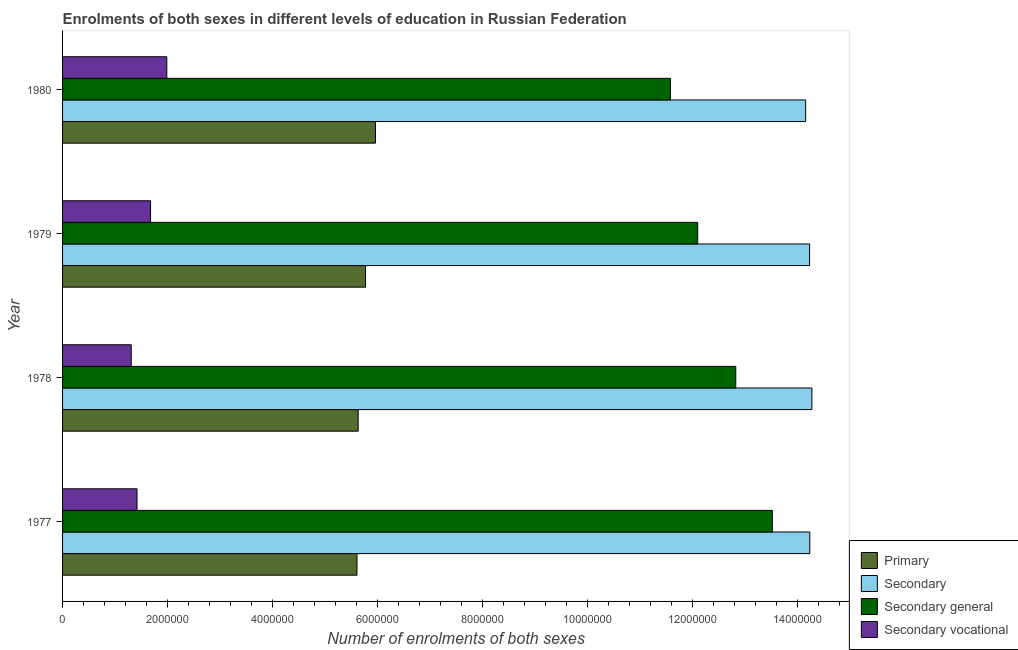Are the number of bars per tick equal to the number of legend labels?
Your answer should be compact. Yes. How many bars are there on the 4th tick from the bottom?
Your answer should be very brief. 4. What is the label of the 1st group of bars from the top?
Provide a succinct answer. 1980. What is the number of enrolments in secondary education in 1978?
Your response must be concise. 1.43e+07. Across all years, what is the maximum number of enrolments in secondary education?
Give a very brief answer. 1.43e+07. Across all years, what is the minimum number of enrolments in secondary education?
Ensure brevity in your answer.  1.42e+07. In which year was the number of enrolments in secondary vocational education maximum?
Give a very brief answer. 1980. In which year was the number of enrolments in secondary vocational education minimum?
Ensure brevity in your answer.  1978. What is the total number of enrolments in primary education in the graph?
Ensure brevity in your answer.  2.30e+07. What is the difference between the number of enrolments in secondary education in 1978 and that in 1979?
Give a very brief answer. 4.33e+04. What is the difference between the number of enrolments in primary education in 1980 and the number of enrolments in secondary vocational education in 1978?
Give a very brief answer. 4.65e+06. What is the average number of enrolments in secondary education per year?
Ensure brevity in your answer.  1.42e+07. In the year 1978, what is the difference between the number of enrolments in secondary general education and number of enrolments in secondary vocational education?
Offer a very short reply. 1.15e+07. In how many years, is the number of enrolments in primary education greater than 8800000 ?
Offer a very short reply. 0. What is the ratio of the number of enrolments in primary education in 1979 to that in 1980?
Your answer should be very brief. 0.97. Is the difference between the number of enrolments in secondary vocational education in 1979 and 1980 greater than the difference between the number of enrolments in primary education in 1979 and 1980?
Make the answer very short. No. What is the difference between the highest and the second highest number of enrolments in secondary education?
Your answer should be very brief. 4.00e+04. What is the difference between the highest and the lowest number of enrolments in secondary education?
Offer a terse response. 1.19e+05. Is the sum of the number of enrolments in secondary education in 1979 and 1980 greater than the maximum number of enrolments in primary education across all years?
Ensure brevity in your answer.  Yes. Is it the case that in every year, the sum of the number of enrolments in secondary general education and number of enrolments in primary education is greater than the sum of number of enrolments in secondary vocational education and number of enrolments in secondary education?
Give a very brief answer. Yes. What does the 3rd bar from the top in 1979 represents?
Your response must be concise. Secondary. What does the 1st bar from the bottom in 1980 represents?
Give a very brief answer. Primary. Is it the case that in every year, the sum of the number of enrolments in primary education and number of enrolments in secondary education is greater than the number of enrolments in secondary general education?
Make the answer very short. Yes. Are all the bars in the graph horizontal?
Provide a succinct answer. Yes. How many years are there in the graph?
Offer a very short reply. 4. Are the values on the major ticks of X-axis written in scientific E-notation?
Your answer should be very brief. No. Does the graph contain any zero values?
Give a very brief answer. No. What is the title of the graph?
Make the answer very short. Enrolments of both sexes in different levels of education in Russian Federation. Does "Structural Policies" appear as one of the legend labels in the graph?
Your response must be concise. No. What is the label or title of the X-axis?
Make the answer very short. Number of enrolments of both sexes. What is the Number of enrolments of both sexes in Primary in 1977?
Your response must be concise. 5.61e+06. What is the Number of enrolments of both sexes in Secondary in 1977?
Offer a very short reply. 1.42e+07. What is the Number of enrolments of both sexes of Secondary general in 1977?
Make the answer very short. 1.35e+07. What is the Number of enrolments of both sexes in Secondary vocational in 1977?
Your answer should be very brief. 1.42e+06. What is the Number of enrolments of both sexes in Primary in 1978?
Your response must be concise. 5.63e+06. What is the Number of enrolments of both sexes of Secondary in 1978?
Your answer should be very brief. 1.43e+07. What is the Number of enrolments of both sexes in Secondary general in 1978?
Give a very brief answer. 1.28e+07. What is the Number of enrolments of both sexes in Secondary vocational in 1978?
Your answer should be compact. 1.31e+06. What is the Number of enrolments of both sexes in Primary in 1979?
Your response must be concise. 5.77e+06. What is the Number of enrolments of both sexes in Secondary in 1979?
Provide a short and direct response. 1.42e+07. What is the Number of enrolments of both sexes in Secondary general in 1979?
Ensure brevity in your answer.  1.21e+07. What is the Number of enrolments of both sexes of Secondary vocational in 1979?
Your answer should be very brief. 1.68e+06. What is the Number of enrolments of both sexes of Primary in 1980?
Offer a terse response. 5.96e+06. What is the Number of enrolments of both sexes in Secondary in 1980?
Give a very brief answer. 1.42e+07. What is the Number of enrolments of both sexes in Secondary general in 1980?
Make the answer very short. 1.16e+07. What is the Number of enrolments of both sexes of Secondary vocational in 1980?
Offer a terse response. 1.99e+06. Across all years, what is the maximum Number of enrolments of both sexes in Primary?
Provide a short and direct response. 5.96e+06. Across all years, what is the maximum Number of enrolments of both sexes of Secondary?
Your answer should be compact. 1.43e+07. Across all years, what is the maximum Number of enrolments of both sexes of Secondary general?
Your answer should be compact. 1.35e+07. Across all years, what is the maximum Number of enrolments of both sexes in Secondary vocational?
Keep it short and to the point. 1.99e+06. Across all years, what is the minimum Number of enrolments of both sexes of Primary?
Offer a terse response. 5.61e+06. Across all years, what is the minimum Number of enrolments of both sexes of Secondary?
Offer a very short reply. 1.42e+07. Across all years, what is the minimum Number of enrolments of both sexes in Secondary general?
Provide a succinct answer. 1.16e+07. Across all years, what is the minimum Number of enrolments of both sexes in Secondary vocational?
Offer a terse response. 1.31e+06. What is the total Number of enrolments of both sexes in Primary in the graph?
Ensure brevity in your answer.  2.30e+07. What is the total Number of enrolments of both sexes in Secondary in the graph?
Provide a succinct answer. 5.69e+07. What is the total Number of enrolments of both sexes of Secondary general in the graph?
Provide a short and direct response. 5.00e+07. What is the total Number of enrolments of both sexes of Secondary vocational in the graph?
Give a very brief answer. 6.39e+06. What is the difference between the Number of enrolments of both sexes in Primary in 1977 and that in 1978?
Your answer should be very brief. -2.30e+04. What is the difference between the Number of enrolments of both sexes of Secondary general in 1977 and that in 1978?
Your answer should be very brief. 6.97e+05. What is the difference between the Number of enrolments of both sexes of Secondary vocational in 1977 and that in 1978?
Offer a very short reply. 1.10e+05. What is the difference between the Number of enrolments of both sexes of Primary in 1977 and that in 1979?
Provide a short and direct response. -1.63e+05. What is the difference between the Number of enrolments of both sexes in Secondary in 1977 and that in 1979?
Offer a terse response. 3320. What is the difference between the Number of enrolments of both sexes of Secondary general in 1977 and that in 1979?
Your answer should be very brief. 1.42e+06. What is the difference between the Number of enrolments of both sexes of Secondary vocational in 1977 and that in 1979?
Your answer should be very brief. -2.58e+05. What is the difference between the Number of enrolments of both sexes in Primary in 1977 and that in 1980?
Offer a very short reply. -3.53e+05. What is the difference between the Number of enrolments of both sexes of Secondary in 1977 and that in 1980?
Make the answer very short. 7.85e+04. What is the difference between the Number of enrolments of both sexes of Secondary general in 1977 and that in 1980?
Keep it short and to the point. 1.94e+06. What is the difference between the Number of enrolments of both sexes of Secondary vocational in 1977 and that in 1980?
Your response must be concise. -5.67e+05. What is the difference between the Number of enrolments of both sexes of Secondary in 1978 and that in 1979?
Give a very brief answer. 4.33e+04. What is the difference between the Number of enrolments of both sexes of Secondary general in 1978 and that in 1979?
Provide a succinct answer. 7.25e+05. What is the difference between the Number of enrolments of both sexes in Secondary vocational in 1978 and that in 1979?
Provide a succinct answer. -3.68e+05. What is the difference between the Number of enrolments of both sexes of Primary in 1978 and that in 1980?
Offer a terse response. -3.30e+05. What is the difference between the Number of enrolments of both sexes in Secondary in 1978 and that in 1980?
Keep it short and to the point. 1.19e+05. What is the difference between the Number of enrolments of both sexes of Secondary general in 1978 and that in 1980?
Your answer should be compact. 1.24e+06. What is the difference between the Number of enrolments of both sexes of Secondary vocational in 1978 and that in 1980?
Make the answer very short. -6.77e+05. What is the difference between the Number of enrolments of both sexes of Primary in 1979 and that in 1980?
Your response must be concise. -1.90e+05. What is the difference between the Number of enrolments of both sexes of Secondary in 1979 and that in 1980?
Your answer should be compact. 7.52e+04. What is the difference between the Number of enrolments of both sexes of Secondary general in 1979 and that in 1980?
Offer a very short reply. 5.20e+05. What is the difference between the Number of enrolments of both sexes of Secondary vocational in 1979 and that in 1980?
Your response must be concise. -3.09e+05. What is the difference between the Number of enrolments of both sexes of Primary in 1977 and the Number of enrolments of both sexes of Secondary in 1978?
Your answer should be compact. -8.66e+06. What is the difference between the Number of enrolments of both sexes of Primary in 1977 and the Number of enrolments of both sexes of Secondary general in 1978?
Offer a very short reply. -7.22e+06. What is the difference between the Number of enrolments of both sexes in Primary in 1977 and the Number of enrolments of both sexes in Secondary vocational in 1978?
Offer a terse response. 4.30e+06. What is the difference between the Number of enrolments of both sexes in Secondary in 1977 and the Number of enrolments of both sexes in Secondary general in 1978?
Provide a succinct answer. 1.41e+06. What is the difference between the Number of enrolments of both sexes of Secondary in 1977 and the Number of enrolments of both sexes of Secondary vocational in 1978?
Provide a succinct answer. 1.29e+07. What is the difference between the Number of enrolments of both sexes in Secondary general in 1977 and the Number of enrolments of both sexes in Secondary vocational in 1978?
Ensure brevity in your answer.  1.22e+07. What is the difference between the Number of enrolments of both sexes in Primary in 1977 and the Number of enrolments of both sexes in Secondary in 1979?
Your response must be concise. -8.62e+06. What is the difference between the Number of enrolments of both sexes in Primary in 1977 and the Number of enrolments of both sexes in Secondary general in 1979?
Your answer should be very brief. -6.49e+06. What is the difference between the Number of enrolments of both sexes of Primary in 1977 and the Number of enrolments of both sexes of Secondary vocational in 1979?
Your response must be concise. 3.93e+06. What is the difference between the Number of enrolments of both sexes in Secondary in 1977 and the Number of enrolments of both sexes in Secondary general in 1979?
Your answer should be very brief. 2.14e+06. What is the difference between the Number of enrolments of both sexes of Secondary in 1977 and the Number of enrolments of both sexes of Secondary vocational in 1979?
Offer a very short reply. 1.26e+07. What is the difference between the Number of enrolments of both sexes of Secondary general in 1977 and the Number of enrolments of both sexes of Secondary vocational in 1979?
Offer a very short reply. 1.18e+07. What is the difference between the Number of enrolments of both sexes of Primary in 1977 and the Number of enrolments of both sexes of Secondary in 1980?
Keep it short and to the point. -8.55e+06. What is the difference between the Number of enrolments of both sexes in Primary in 1977 and the Number of enrolments of both sexes in Secondary general in 1980?
Make the answer very short. -5.97e+06. What is the difference between the Number of enrolments of both sexes in Primary in 1977 and the Number of enrolments of both sexes in Secondary vocational in 1980?
Ensure brevity in your answer.  3.62e+06. What is the difference between the Number of enrolments of both sexes of Secondary in 1977 and the Number of enrolments of both sexes of Secondary general in 1980?
Provide a succinct answer. 2.66e+06. What is the difference between the Number of enrolments of both sexes in Secondary in 1977 and the Number of enrolments of both sexes in Secondary vocational in 1980?
Provide a short and direct response. 1.22e+07. What is the difference between the Number of enrolments of both sexes of Secondary general in 1977 and the Number of enrolments of both sexes of Secondary vocational in 1980?
Your answer should be compact. 1.15e+07. What is the difference between the Number of enrolments of both sexes of Primary in 1978 and the Number of enrolments of both sexes of Secondary in 1979?
Ensure brevity in your answer.  -8.60e+06. What is the difference between the Number of enrolments of both sexes in Primary in 1978 and the Number of enrolments of both sexes in Secondary general in 1979?
Your answer should be very brief. -6.47e+06. What is the difference between the Number of enrolments of both sexes of Primary in 1978 and the Number of enrolments of both sexes of Secondary vocational in 1979?
Your answer should be very brief. 3.96e+06. What is the difference between the Number of enrolments of both sexes in Secondary in 1978 and the Number of enrolments of both sexes in Secondary general in 1979?
Your response must be concise. 2.18e+06. What is the difference between the Number of enrolments of both sexes of Secondary in 1978 and the Number of enrolments of both sexes of Secondary vocational in 1979?
Your answer should be compact. 1.26e+07. What is the difference between the Number of enrolments of both sexes in Secondary general in 1978 and the Number of enrolments of both sexes in Secondary vocational in 1979?
Your response must be concise. 1.11e+07. What is the difference between the Number of enrolments of both sexes of Primary in 1978 and the Number of enrolments of both sexes of Secondary in 1980?
Give a very brief answer. -8.52e+06. What is the difference between the Number of enrolments of both sexes of Primary in 1978 and the Number of enrolments of both sexes of Secondary general in 1980?
Offer a very short reply. -5.95e+06. What is the difference between the Number of enrolments of both sexes in Primary in 1978 and the Number of enrolments of both sexes in Secondary vocational in 1980?
Provide a succinct answer. 3.65e+06. What is the difference between the Number of enrolments of both sexes in Secondary in 1978 and the Number of enrolments of both sexes in Secondary general in 1980?
Provide a succinct answer. 2.70e+06. What is the difference between the Number of enrolments of both sexes in Secondary in 1978 and the Number of enrolments of both sexes in Secondary vocational in 1980?
Offer a terse response. 1.23e+07. What is the difference between the Number of enrolments of both sexes of Secondary general in 1978 and the Number of enrolments of both sexes of Secondary vocational in 1980?
Make the answer very short. 1.08e+07. What is the difference between the Number of enrolments of both sexes of Primary in 1979 and the Number of enrolments of both sexes of Secondary in 1980?
Your answer should be compact. -8.38e+06. What is the difference between the Number of enrolments of both sexes in Primary in 1979 and the Number of enrolments of both sexes in Secondary general in 1980?
Provide a succinct answer. -5.81e+06. What is the difference between the Number of enrolments of both sexes in Primary in 1979 and the Number of enrolments of both sexes in Secondary vocational in 1980?
Give a very brief answer. 3.79e+06. What is the difference between the Number of enrolments of both sexes of Secondary in 1979 and the Number of enrolments of both sexes of Secondary general in 1980?
Make the answer very short. 2.65e+06. What is the difference between the Number of enrolments of both sexes of Secondary in 1979 and the Number of enrolments of both sexes of Secondary vocational in 1980?
Ensure brevity in your answer.  1.22e+07. What is the difference between the Number of enrolments of both sexes in Secondary general in 1979 and the Number of enrolments of both sexes in Secondary vocational in 1980?
Your answer should be compact. 1.01e+07. What is the average Number of enrolments of both sexes in Primary per year?
Make the answer very short. 5.74e+06. What is the average Number of enrolments of both sexes of Secondary per year?
Your answer should be compact. 1.42e+07. What is the average Number of enrolments of both sexes in Secondary general per year?
Make the answer very short. 1.25e+07. What is the average Number of enrolments of both sexes in Secondary vocational per year?
Your response must be concise. 1.60e+06. In the year 1977, what is the difference between the Number of enrolments of both sexes in Primary and Number of enrolments of both sexes in Secondary?
Provide a succinct answer. -8.62e+06. In the year 1977, what is the difference between the Number of enrolments of both sexes in Primary and Number of enrolments of both sexes in Secondary general?
Keep it short and to the point. -7.91e+06. In the year 1977, what is the difference between the Number of enrolments of both sexes of Primary and Number of enrolments of both sexes of Secondary vocational?
Your response must be concise. 4.19e+06. In the year 1977, what is the difference between the Number of enrolments of both sexes of Secondary and Number of enrolments of both sexes of Secondary general?
Keep it short and to the point. 7.13e+05. In the year 1977, what is the difference between the Number of enrolments of both sexes of Secondary and Number of enrolments of both sexes of Secondary vocational?
Ensure brevity in your answer.  1.28e+07. In the year 1977, what is the difference between the Number of enrolments of both sexes in Secondary general and Number of enrolments of both sexes in Secondary vocational?
Your answer should be very brief. 1.21e+07. In the year 1978, what is the difference between the Number of enrolments of both sexes of Primary and Number of enrolments of both sexes of Secondary?
Ensure brevity in your answer.  -8.64e+06. In the year 1978, what is the difference between the Number of enrolments of both sexes of Primary and Number of enrolments of both sexes of Secondary general?
Your response must be concise. -7.19e+06. In the year 1978, what is the difference between the Number of enrolments of both sexes in Primary and Number of enrolments of both sexes in Secondary vocational?
Your answer should be compact. 4.32e+06. In the year 1978, what is the difference between the Number of enrolments of both sexes of Secondary and Number of enrolments of both sexes of Secondary general?
Offer a terse response. 1.45e+06. In the year 1978, what is the difference between the Number of enrolments of both sexes in Secondary and Number of enrolments of both sexes in Secondary vocational?
Ensure brevity in your answer.  1.30e+07. In the year 1978, what is the difference between the Number of enrolments of both sexes of Secondary general and Number of enrolments of both sexes of Secondary vocational?
Keep it short and to the point. 1.15e+07. In the year 1979, what is the difference between the Number of enrolments of both sexes in Primary and Number of enrolments of both sexes in Secondary?
Give a very brief answer. -8.46e+06. In the year 1979, what is the difference between the Number of enrolments of both sexes of Primary and Number of enrolments of both sexes of Secondary general?
Ensure brevity in your answer.  -6.33e+06. In the year 1979, what is the difference between the Number of enrolments of both sexes in Primary and Number of enrolments of both sexes in Secondary vocational?
Your response must be concise. 4.10e+06. In the year 1979, what is the difference between the Number of enrolments of both sexes of Secondary and Number of enrolments of both sexes of Secondary general?
Keep it short and to the point. 2.13e+06. In the year 1979, what is the difference between the Number of enrolments of both sexes in Secondary and Number of enrolments of both sexes in Secondary vocational?
Make the answer very short. 1.26e+07. In the year 1979, what is the difference between the Number of enrolments of both sexes in Secondary general and Number of enrolments of both sexes in Secondary vocational?
Make the answer very short. 1.04e+07. In the year 1980, what is the difference between the Number of enrolments of both sexes of Primary and Number of enrolments of both sexes of Secondary?
Your response must be concise. -8.19e+06. In the year 1980, what is the difference between the Number of enrolments of both sexes in Primary and Number of enrolments of both sexes in Secondary general?
Your response must be concise. -5.62e+06. In the year 1980, what is the difference between the Number of enrolments of both sexes in Primary and Number of enrolments of both sexes in Secondary vocational?
Give a very brief answer. 3.98e+06. In the year 1980, what is the difference between the Number of enrolments of both sexes in Secondary and Number of enrolments of both sexes in Secondary general?
Your answer should be compact. 2.58e+06. In the year 1980, what is the difference between the Number of enrolments of both sexes of Secondary and Number of enrolments of both sexes of Secondary vocational?
Your answer should be very brief. 1.22e+07. In the year 1980, what is the difference between the Number of enrolments of both sexes in Secondary general and Number of enrolments of both sexes in Secondary vocational?
Your answer should be very brief. 9.59e+06. What is the ratio of the Number of enrolments of both sexes in Secondary in 1977 to that in 1978?
Ensure brevity in your answer.  1. What is the ratio of the Number of enrolments of both sexes of Secondary general in 1977 to that in 1978?
Give a very brief answer. 1.05. What is the ratio of the Number of enrolments of both sexes in Secondary vocational in 1977 to that in 1978?
Offer a very short reply. 1.08. What is the ratio of the Number of enrolments of both sexes of Primary in 1977 to that in 1979?
Provide a short and direct response. 0.97. What is the ratio of the Number of enrolments of both sexes in Secondary in 1977 to that in 1979?
Offer a terse response. 1. What is the ratio of the Number of enrolments of both sexes of Secondary general in 1977 to that in 1979?
Give a very brief answer. 1.12. What is the ratio of the Number of enrolments of both sexes in Secondary vocational in 1977 to that in 1979?
Offer a very short reply. 0.85. What is the ratio of the Number of enrolments of both sexes of Primary in 1977 to that in 1980?
Offer a terse response. 0.94. What is the ratio of the Number of enrolments of both sexes in Secondary general in 1977 to that in 1980?
Your answer should be very brief. 1.17. What is the ratio of the Number of enrolments of both sexes in Primary in 1978 to that in 1979?
Your response must be concise. 0.98. What is the ratio of the Number of enrolments of both sexes of Secondary in 1978 to that in 1979?
Your response must be concise. 1. What is the ratio of the Number of enrolments of both sexes of Secondary general in 1978 to that in 1979?
Provide a succinct answer. 1.06. What is the ratio of the Number of enrolments of both sexes of Secondary vocational in 1978 to that in 1979?
Provide a succinct answer. 0.78. What is the ratio of the Number of enrolments of both sexes in Primary in 1978 to that in 1980?
Provide a succinct answer. 0.94. What is the ratio of the Number of enrolments of both sexes of Secondary in 1978 to that in 1980?
Offer a terse response. 1.01. What is the ratio of the Number of enrolments of both sexes of Secondary general in 1978 to that in 1980?
Give a very brief answer. 1.11. What is the ratio of the Number of enrolments of both sexes of Secondary vocational in 1978 to that in 1980?
Offer a terse response. 0.66. What is the ratio of the Number of enrolments of both sexes of Primary in 1979 to that in 1980?
Provide a short and direct response. 0.97. What is the ratio of the Number of enrolments of both sexes in Secondary general in 1979 to that in 1980?
Provide a succinct answer. 1.04. What is the ratio of the Number of enrolments of both sexes in Secondary vocational in 1979 to that in 1980?
Your answer should be compact. 0.84. What is the difference between the highest and the second highest Number of enrolments of both sexes of Primary?
Ensure brevity in your answer.  1.90e+05. What is the difference between the highest and the second highest Number of enrolments of both sexes in Secondary?
Your answer should be very brief. 4.00e+04. What is the difference between the highest and the second highest Number of enrolments of both sexes of Secondary general?
Make the answer very short. 6.97e+05. What is the difference between the highest and the second highest Number of enrolments of both sexes in Secondary vocational?
Give a very brief answer. 3.09e+05. What is the difference between the highest and the lowest Number of enrolments of both sexes in Primary?
Provide a succinct answer. 3.53e+05. What is the difference between the highest and the lowest Number of enrolments of both sexes in Secondary?
Offer a very short reply. 1.19e+05. What is the difference between the highest and the lowest Number of enrolments of both sexes of Secondary general?
Your answer should be very brief. 1.94e+06. What is the difference between the highest and the lowest Number of enrolments of both sexes in Secondary vocational?
Provide a short and direct response. 6.77e+05. 